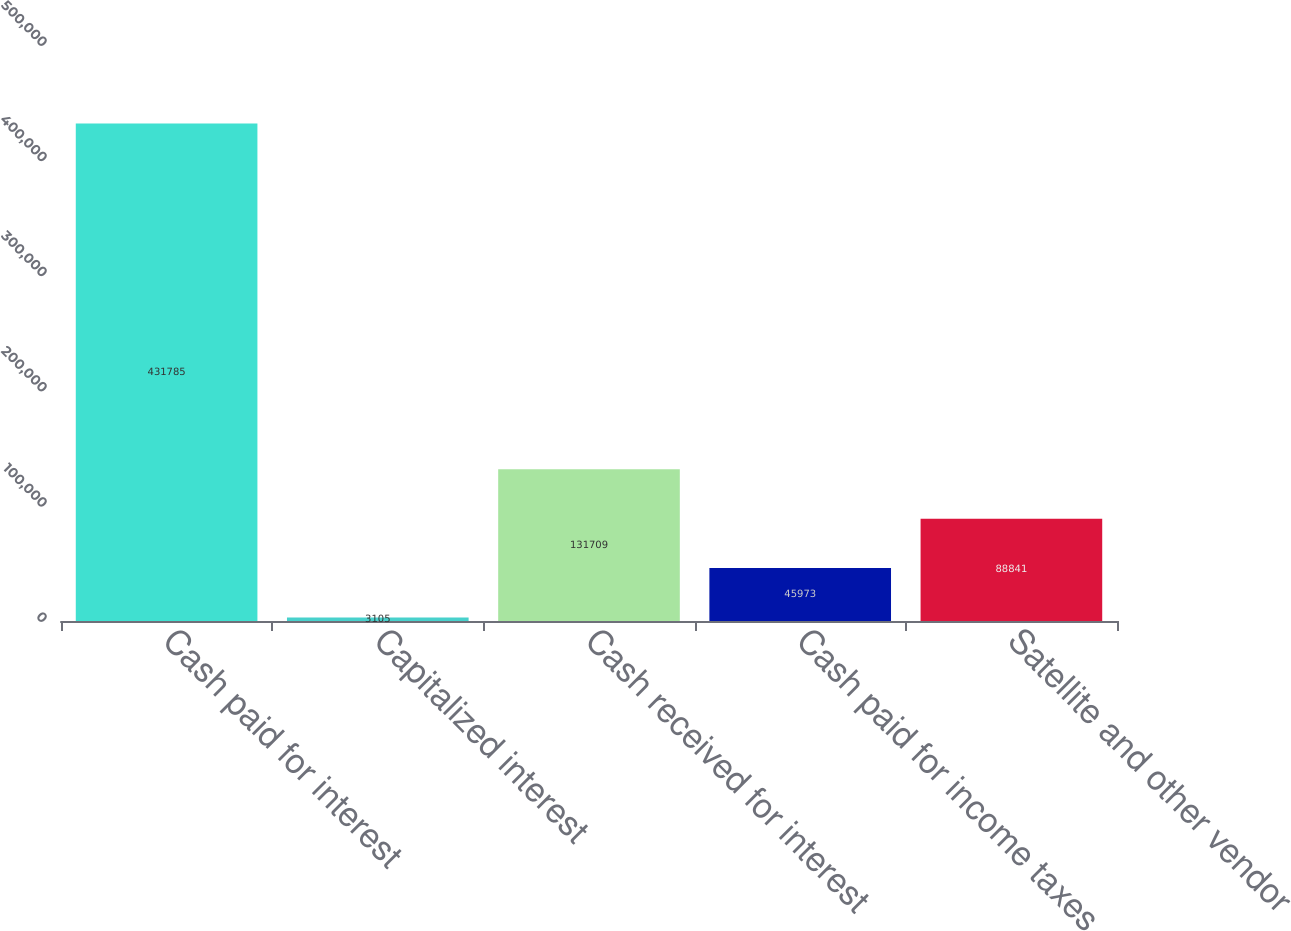Convert chart to OTSL. <chart><loc_0><loc_0><loc_500><loc_500><bar_chart><fcel>Cash paid for interest<fcel>Capitalized interest<fcel>Cash received for interest<fcel>Cash paid for income taxes<fcel>Satellite and other vendor<nl><fcel>431785<fcel>3105<fcel>131709<fcel>45973<fcel>88841<nl></chart> 